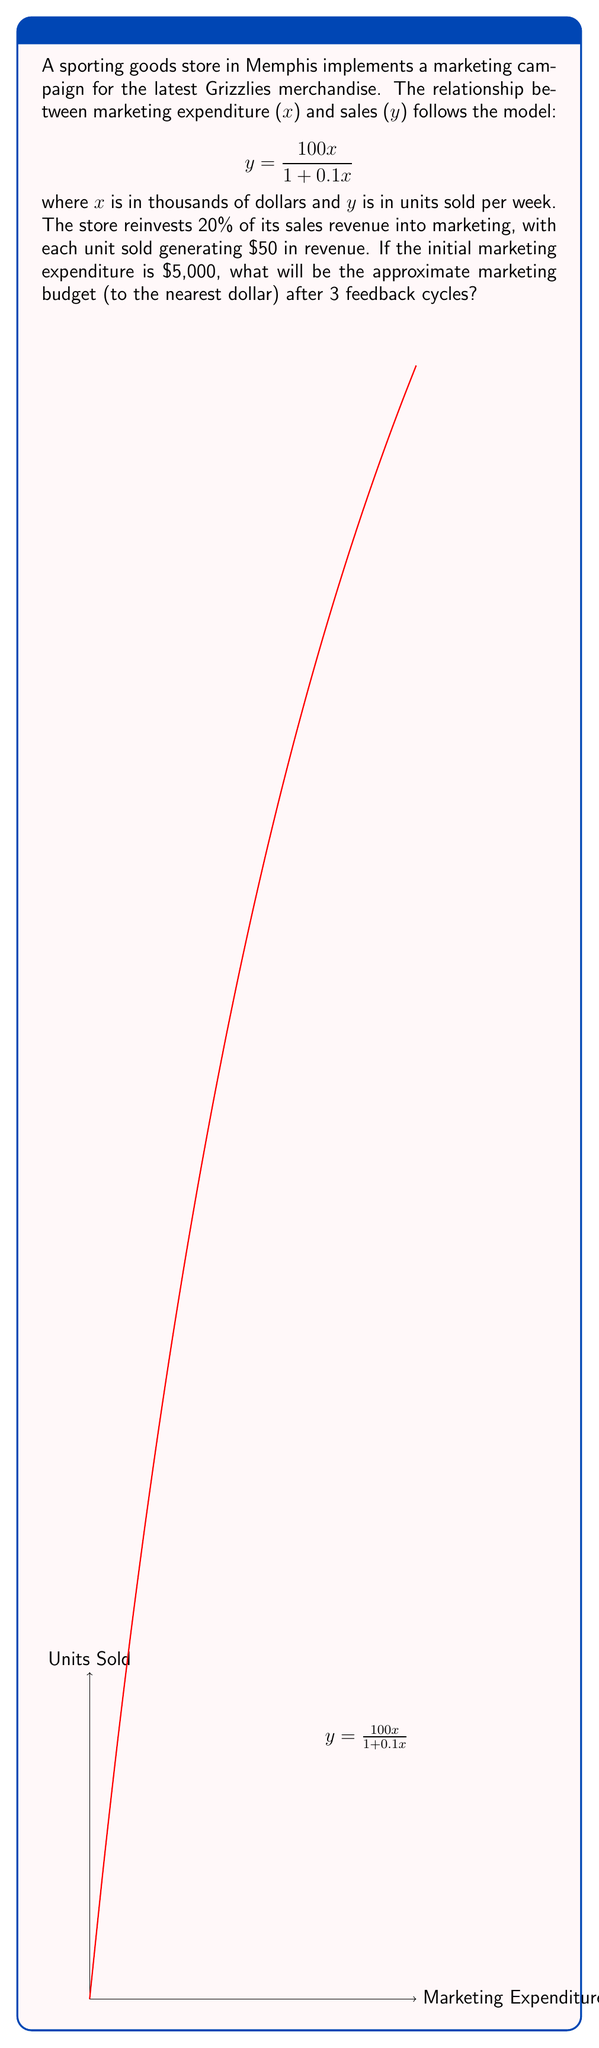Give your solution to this math problem. Let's solve this step-by-step:

1) Initial marketing expenditure: $x_0 = 5$ thousand dollars = $5,000

2) For each cycle i, we calculate:
   a) Units sold: $y_i = \frac{100x_i}{1 + 0.1x_i}$
   b) Revenue: $R_i = 50y_i$
   c) Next marketing budget: $x_{i+1} = 0.2R_i = 10y_i$

3) First cycle:
   $y_1 = \frac{100(5)}{1 + 0.1(5)} = \frac{500}{1.5} = 333.33$ units
   $x_2 = 10(333.33) = 3,333.33$

4) Second cycle:
   $y_2 = \frac{100(3.33333)}{1 + 0.1(3.33333)} = \frac{333.333}{1.33333} = 250$ units
   $x_3 = 10(250) = 2,500$

5) Third cycle:
   $y_3 = \frac{100(2.5)}{1 + 0.1(2.5)} = \frac{250}{1.25} = 200$ units
   $x_4 = 10(200) = 2,000$

Therefore, after 3 feedback cycles, the marketing budget will be approximately $2,000.
Answer: $2,000 